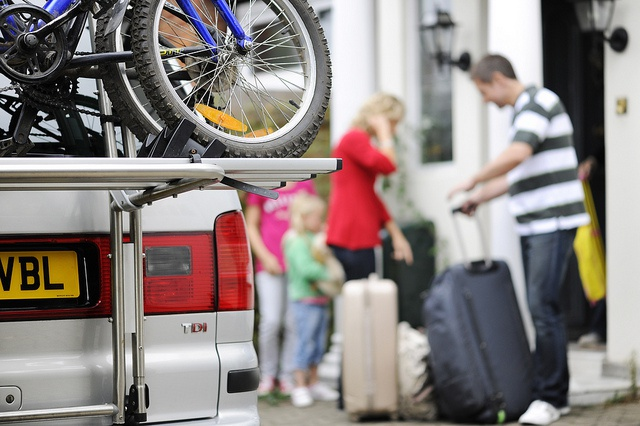Describe the objects in this image and their specific colors. I can see car in blue, darkgray, lightgray, black, and brown tones, bicycle in blue, black, gray, darkgray, and lightgray tones, people in blue, lavender, black, gray, and darkgray tones, suitcase in blue, gray, black, and lightgray tones, and people in blue, brown, red, and tan tones in this image. 